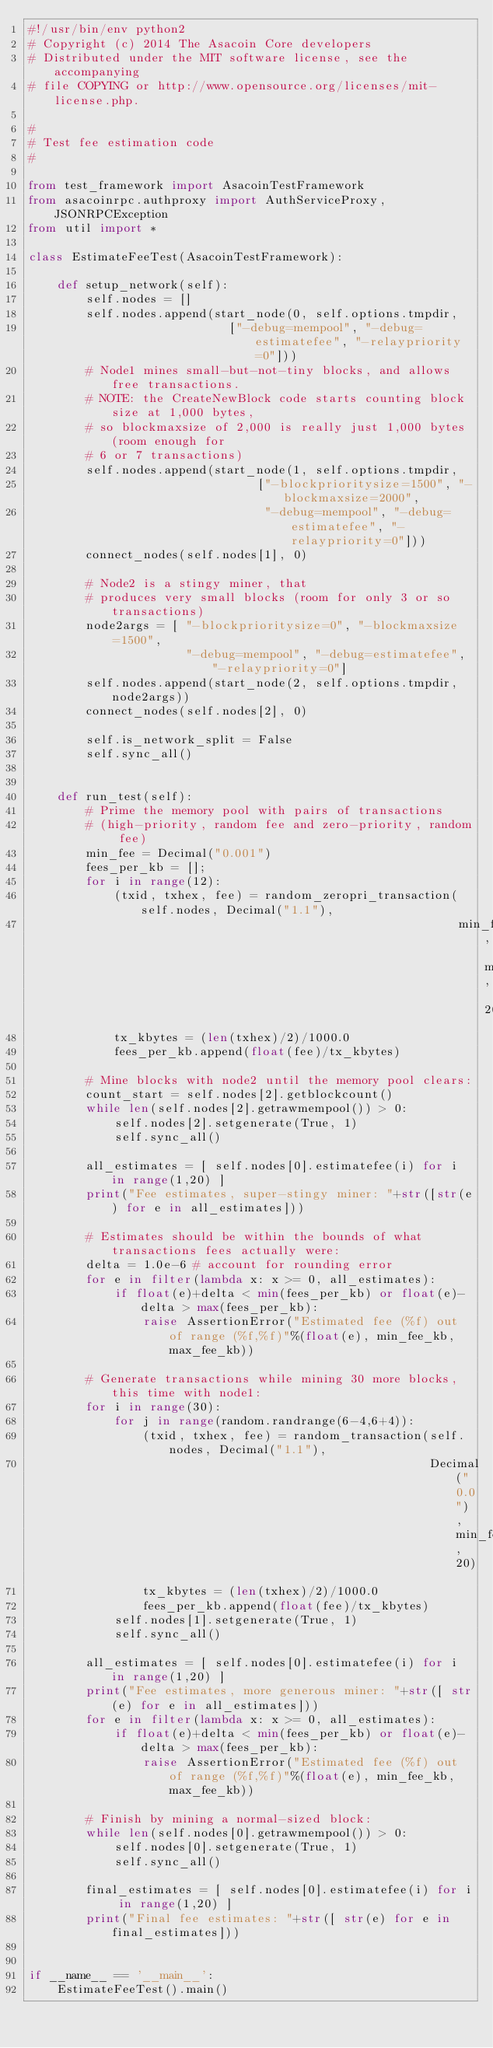Convert code to text. <code><loc_0><loc_0><loc_500><loc_500><_Python_>#!/usr/bin/env python2
# Copyright (c) 2014 The Asacoin Core developers
# Distributed under the MIT software license, see the accompanying
# file COPYING or http://www.opensource.org/licenses/mit-license.php.

#
# Test fee estimation code
#

from test_framework import AsacoinTestFramework
from asacoinrpc.authproxy import AuthServiceProxy, JSONRPCException
from util import *

class EstimateFeeTest(AsacoinTestFramework):

    def setup_network(self):
        self.nodes = []
        self.nodes.append(start_node(0, self.options.tmpdir,
                            ["-debug=mempool", "-debug=estimatefee", "-relaypriority=0"]))
        # Node1 mines small-but-not-tiny blocks, and allows free transactions.
        # NOTE: the CreateNewBlock code starts counting block size at 1,000 bytes,
        # so blockmaxsize of 2,000 is really just 1,000 bytes (room enough for
        # 6 or 7 transactions)
        self.nodes.append(start_node(1, self.options.tmpdir,
                                ["-blockprioritysize=1500", "-blockmaxsize=2000",
                                 "-debug=mempool", "-debug=estimatefee", "-relaypriority=0"]))
        connect_nodes(self.nodes[1], 0)

        # Node2 is a stingy miner, that
        # produces very small blocks (room for only 3 or so transactions)
        node2args = [ "-blockprioritysize=0", "-blockmaxsize=1500",
                      "-debug=mempool", "-debug=estimatefee", "-relaypriority=0"]
        self.nodes.append(start_node(2, self.options.tmpdir, node2args))
        connect_nodes(self.nodes[2], 0)

        self.is_network_split = False
        self.sync_all()
        

    def run_test(self):
        # Prime the memory pool with pairs of transactions
        # (high-priority, random fee and zero-priority, random fee)
        min_fee = Decimal("0.001")
        fees_per_kb = [];
        for i in range(12):
            (txid, txhex, fee) = random_zeropri_transaction(self.nodes, Decimal("1.1"),
                                                            min_fee, min_fee, 20)
            tx_kbytes = (len(txhex)/2)/1000.0
            fees_per_kb.append(float(fee)/tx_kbytes)

        # Mine blocks with node2 until the memory pool clears:
        count_start = self.nodes[2].getblockcount()
        while len(self.nodes[2].getrawmempool()) > 0:
            self.nodes[2].setgenerate(True, 1)
            self.sync_all()

        all_estimates = [ self.nodes[0].estimatefee(i) for i in range(1,20) ]
        print("Fee estimates, super-stingy miner: "+str([str(e) for e in all_estimates]))

        # Estimates should be within the bounds of what transactions fees actually were:
        delta = 1.0e-6 # account for rounding error
        for e in filter(lambda x: x >= 0, all_estimates):
            if float(e)+delta < min(fees_per_kb) or float(e)-delta > max(fees_per_kb):
                raise AssertionError("Estimated fee (%f) out of range (%f,%f)"%(float(e), min_fee_kb, max_fee_kb))

        # Generate transactions while mining 30 more blocks, this time with node1:
        for i in range(30):
            for j in range(random.randrange(6-4,6+4)):
                (txid, txhex, fee) = random_transaction(self.nodes, Decimal("1.1"),
                                                        Decimal("0.0"), min_fee, 20)
                tx_kbytes = (len(txhex)/2)/1000.0
                fees_per_kb.append(float(fee)/tx_kbytes)
            self.nodes[1].setgenerate(True, 1)
            self.sync_all()

        all_estimates = [ self.nodes[0].estimatefee(i) for i in range(1,20) ]
        print("Fee estimates, more generous miner: "+str([ str(e) for e in all_estimates]))
        for e in filter(lambda x: x >= 0, all_estimates):
            if float(e)+delta < min(fees_per_kb) or float(e)-delta > max(fees_per_kb):
                raise AssertionError("Estimated fee (%f) out of range (%f,%f)"%(float(e), min_fee_kb, max_fee_kb))

        # Finish by mining a normal-sized block:
        while len(self.nodes[0].getrawmempool()) > 0:
            self.nodes[0].setgenerate(True, 1)
            self.sync_all()

        final_estimates = [ self.nodes[0].estimatefee(i) for i in range(1,20) ]
        print("Final fee estimates: "+str([ str(e) for e in final_estimates]))


if __name__ == '__main__':
    EstimateFeeTest().main()
</code> 